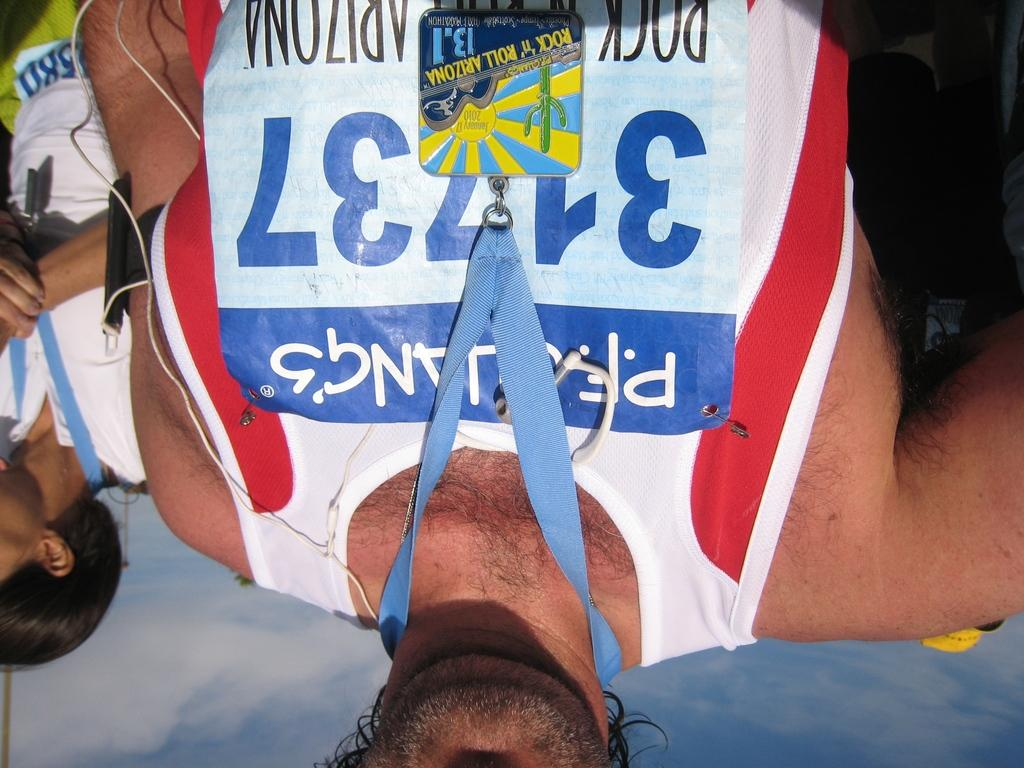<image>
Write a terse but informative summary of the picture. A man is wearing a Rock 'n' Roll Arizona tag around his neck. 